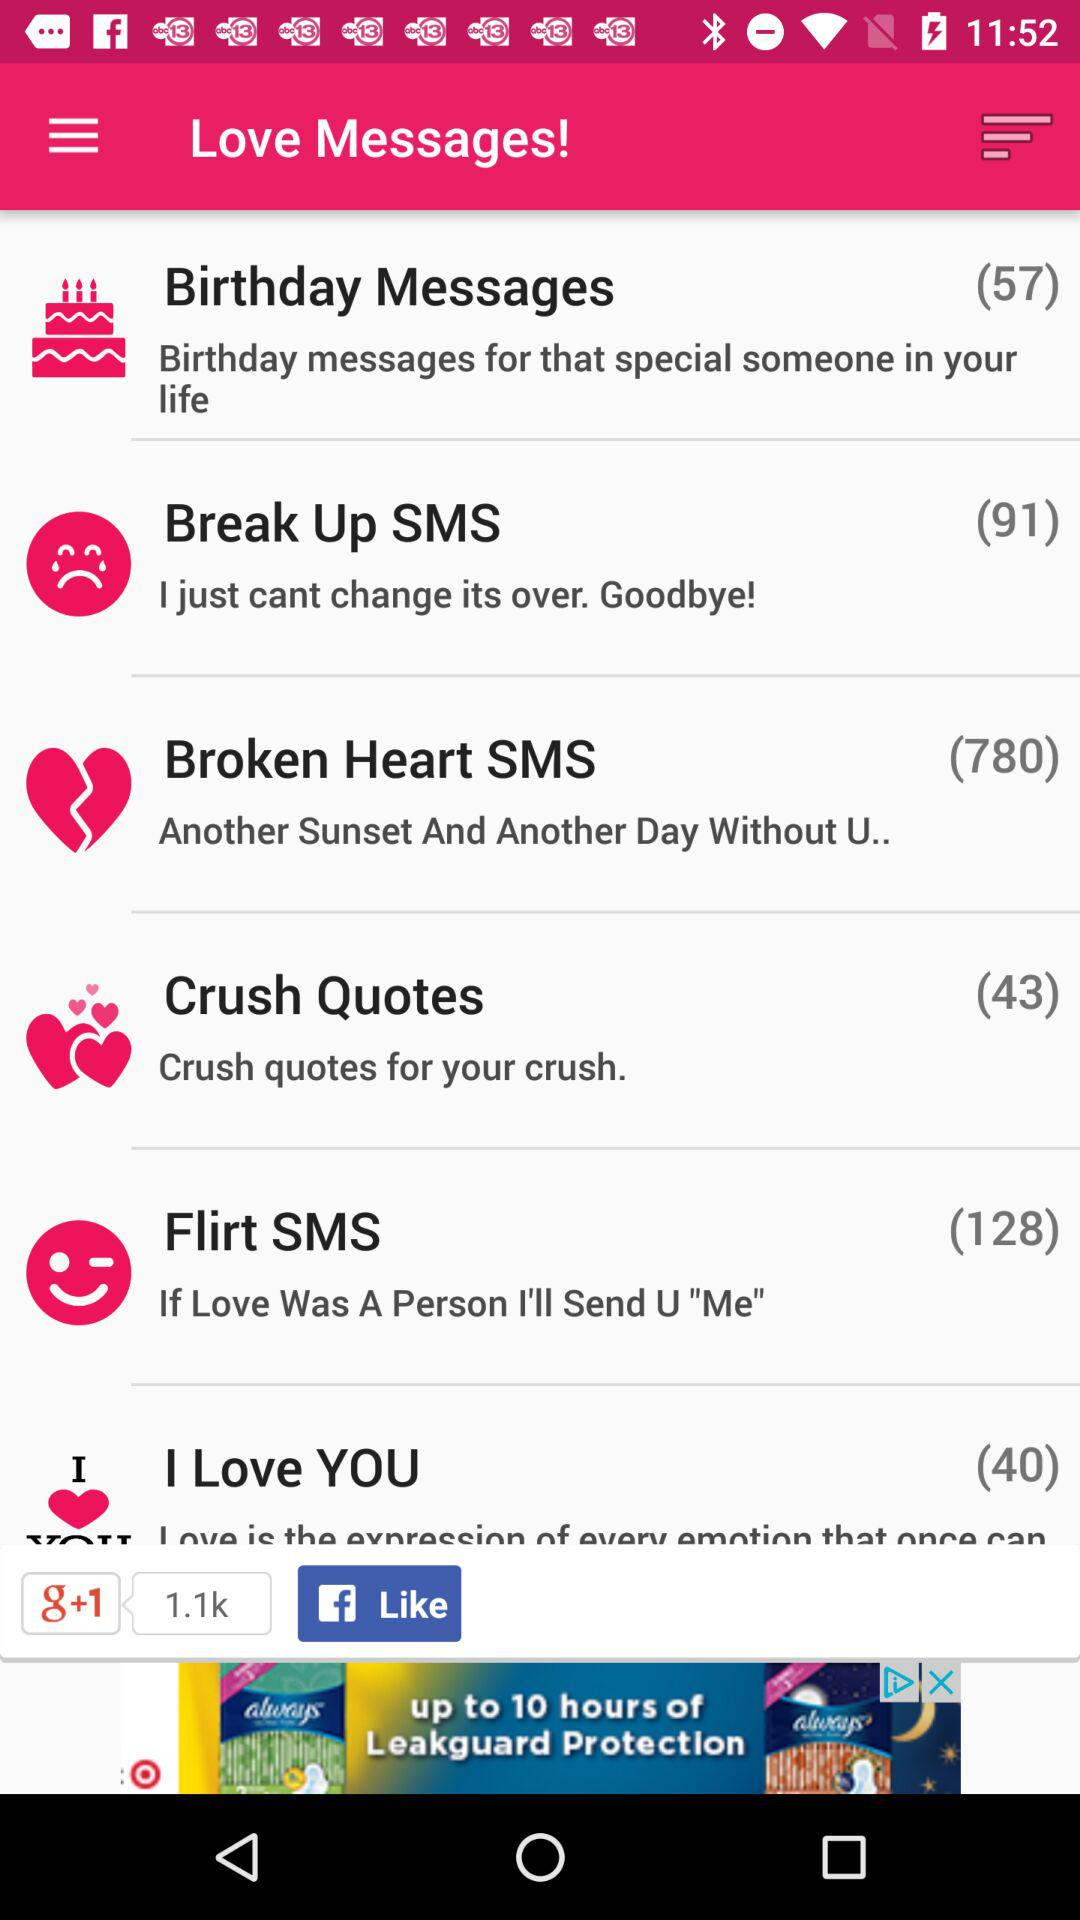Which option has 91 messages? The option that has 91 messages is "Break Up SMS". 